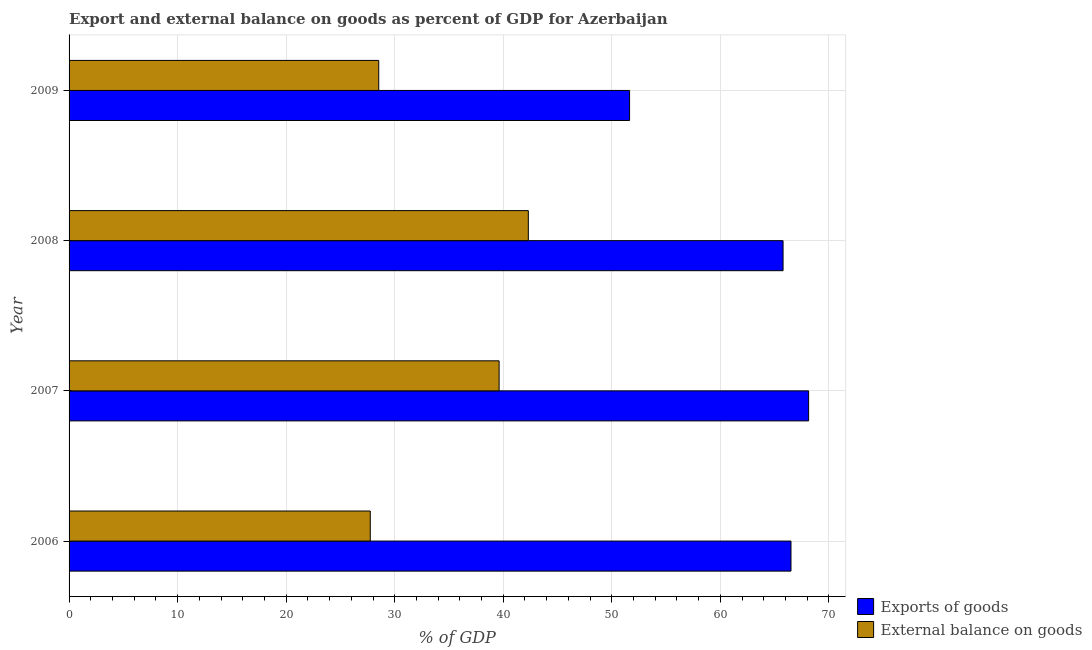How many different coloured bars are there?
Keep it short and to the point. 2. How many groups of bars are there?
Provide a succinct answer. 4. How many bars are there on the 2nd tick from the top?
Give a very brief answer. 2. What is the label of the 2nd group of bars from the top?
Provide a short and direct response. 2008. In how many cases, is the number of bars for a given year not equal to the number of legend labels?
Offer a terse response. 0. What is the external balance on goods as percentage of gdp in 2006?
Provide a succinct answer. 27.75. Across all years, what is the maximum export of goods as percentage of gdp?
Make the answer very short. 68.13. Across all years, what is the minimum external balance on goods as percentage of gdp?
Give a very brief answer. 27.75. In which year was the external balance on goods as percentage of gdp maximum?
Give a very brief answer. 2008. What is the total external balance on goods as percentage of gdp in the graph?
Your response must be concise. 138.2. What is the difference between the external balance on goods as percentage of gdp in 2006 and that in 2008?
Your answer should be compact. -14.56. What is the difference between the export of goods as percentage of gdp in 2008 and the external balance on goods as percentage of gdp in 2007?
Provide a short and direct response. 26.16. What is the average export of goods as percentage of gdp per year?
Provide a short and direct response. 63.01. In the year 2008, what is the difference between the external balance on goods as percentage of gdp and export of goods as percentage of gdp?
Offer a very short reply. -23.47. In how many years, is the export of goods as percentage of gdp greater than 6 %?
Make the answer very short. 4. What is the ratio of the external balance on goods as percentage of gdp in 2007 to that in 2008?
Your answer should be very brief. 0.94. Is the difference between the external balance on goods as percentage of gdp in 2006 and 2008 greater than the difference between the export of goods as percentage of gdp in 2006 and 2008?
Make the answer very short. No. What is the difference between the highest and the second highest export of goods as percentage of gdp?
Your answer should be compact. 1.62. In how many years, is the export of goods as percentage of gdp greater than the average export of goods as percentage of gdp taken over all years?
Your answer should be compact. 3. What does the 1st bar from the top in 2009 represents?
Offer a terse response. External balance on goods. What does the 2nd bar from the bottom in 2006 represents?
Your answer should be compact. External balance on goods. Are all the bars in the graph horizontal?
Make the answer very short. Yes. What is the difference between two consecutive major ticks on the X-axis?
Offer a very short reply. 10. How many legend labels are there?
Your answer should be compact. 2. What is the title of the graph?
Provide a succinct answer. Export and external balance on goods as percent of GDP for Azerbaijan. Does "Primary education" appear as one of the legend labels in the graph?
Offer a terse response. No. What is the label or title of the X-axis?
Give a very brief answer. % of GDP. What is the % of GDP in Exports of goods in 2006?
Keep it short and to the point. 66.51. What is the % of GDP of External balance on goods in 2006?
Your answer should be very brief. 27.75. What is the % of GDP in Exports of goods in 2007?
Your answer should be compact. 68.13. What is the % of GDP of External balance on goods in 2007?
Ensure brevity in your answer.  39.62. What is the % of GDP of Exports of goods in 2008?
Make the answer very short. 65.78. What is the % of GDP of External balance on goods in 2008?
Give a very brief answer. 42.31. What is the % of GDP in Exports of goods in 2009?
Offer a terse response. 51.64. What is the % of GDP of External balance on goods in 2009?
Provide a short and direct response. 28.53. Across all years, what is the maximum % of GDP in Exports of goods?
Ensure brevity in your answer.  68.13. Across all years, what is the maximum % of GDP of External balance on goods?
Your response must be concise. 42.31. Across all years, what is the minimum % of GDP in Exports of goods?
Offer a terse response. 51.64. Across all years, what is the minimum % of GDP of External balance on goods?
Ensure brevity in your answer.  27.75. What is the total % of GDP of Exports of goods in the graph?
Make the answer very short. 252.05. What is the total % of GDP of External balance on goods in the graph?
Offer a terse response. 138.2. What is the difference between the % of GDP in Exports of goods in 2006 and that in 2007?
Offer a terse response. -1.62. What is the difference between the % of GDP in External balance on goods in 2006 and that in 2007?
Your answer should be compact. -11.87. What is the difference between the % of GDP of Exports of goods in 2006 and that in 2008?
Provide a succinct answer. 0.73. What is the difference between the % of GDP in External balance on goods in 2006 and that in 2008?
Provide a succinct answer. -14.56. What is the difference between the % of GDP in Exports of goods in 2006 and that in 2009?
Give a very brief answer. 14.87. What is the difference between the % of GDP of External balance on goods in 2006 and that in 2009?
Provide a short and direct response. -0.78. What is the difference between the % of GDP of Exports of goods in 2007 and that in 2008?
Offer a terse response. 2.35. What is the difference between the % of GDP in External balance on goods in 2007 and that in 2008?
Your answer should be very brief. -2.69. What is the difference between the % of GDP of Exports of goods in 2007 and that in 2009?
Keep it short and to the point. 16.5. What is the difference between the % of GDP of External balance on goods in 2007 and that in 2009?
Make the answer very short. 11.09. What is the difference between the % of GDP of Exports of goods in 2008 and that in 2009?
Ensure brevity in your answer.  14.14. What is the difference between the % of GDP of External balance on goods in 2008 and that in 2009?
Your answer should be very brief. 13.78. What is the difference between the % of GDP of Exports of goods in 2006 and the % of GDP of External balance on goods in 2007?
Provide a short and direct response. 26.89. What is the difference between the % of GDP of Exports of goods in 2006 and the % of GDP of External balance on goods in 2008?
Provide a short and direct response. 24.2. What is the difference between the % of GDP of Exports of goods in 2006 and the % of GDP of External balance on goods in 2009?
Your answer should be compact. 37.98. What is the difference between the % of GDP of Exports of goods in 2007 and the % of GDP of External balance on goods in 2008?
Ensure brevity in your answer.  25.82. What is the difference between the % of GDP of Exports of goods in 2007 and the % of GDP of External balance on goods in 2009?
Your answer should be very brief. 39.6. What is the difference between the % of GDP of Exports of goods in 2008 and the % of GDP of External balance on goods in 2009?
Your answer should be compact. 37.25. What is the average % of GDP in Exports of goods per year?
Offer a terse response. 63.01. What is the average % of GDP in External balance on goods per year?
Give a very brief answer. 34.55. In the year 2006, what is the difference between the % of GDP of Exports of goods and % of GDP of External balance on goods?
Your answer should be compact. 38.76. In the year 2007, what is the difference between the % of GDP in Exports of goods and % of GDP in External balance on goods?
Keep it short and to the point. 28.51. In the year 2008, what is the difference between the % of GDP of Exports of goods and % of GDP of External balance on goods?
Keep it short and to the point. 23.47. In the year 2009, what is the difference between the % of GDP of Exports of goods and % of GDP of External balance on goods?
Your answer should be compact. 23.11. What is the ratio of the % of GDP of Exports of goods in 2006 to that in 2007?
Offer a very short reply. 0.98. What is the ratio of the % of GDP in External balance on goods in 2006 to that in 2007?
Provide a short and direct response. 0.7. What is the ratio of the % of GDP in Exports of goods in 2006 to that in 2008?
Your answer should be very brief. 1.01. What is the ratio of the % of GDP of External balance on goods in 2006 to that in 2008?
Offer a terse response. 0.66. What is the ratio of the % of GDP in Exports of goods in 2006 to that in 2009?
Ensure brevity in your answer.  1.29. What is the ratio of the % of GDP of External balance on goods in 2006 to that in 2009?
Keep it short and to the point. 0.97. What is the ratio of the % of GDP of Exports of goods in 2007 to that in 2008?
Make the answer very short. 1.04. What is the ratio of the % of GDP in External balance on goods in 2007 to that in 2008?
Give a very brief answer. 0.94. What is the ratio of the % of GDP of Exports of goods in 2007 to that in 2009?
Your response must be concise. 1.32. What is the ratio of the % of GDP in External balance on goods in 2007 to that in 2009?
Provide a short and direct response. 1.39. What is the ratio of the % of GDP of Exports of goods in 2008 to that in 2009?
Give a very brief answer. 1.27. What is the ratio of the % of GDP of External balance on goods in 2008 to that in 2009?
Provide a succinct answer. 1.48. What is the difference between the highest and the second highest % of GDP of Exports of goods?
Your answer should be very brief. 1.62. What is the difference between the highest and the second highest % of GDP of External balance on goods?
Give a very brief answer. 2.69. What is the difference between the highest and the lowest % of GDP in Exports of goods?
Your response must be concise. 16.5. What is the difference between the highest and the lowest % of GDP in External balance on goods?
Offer a terse response. 14.56. 